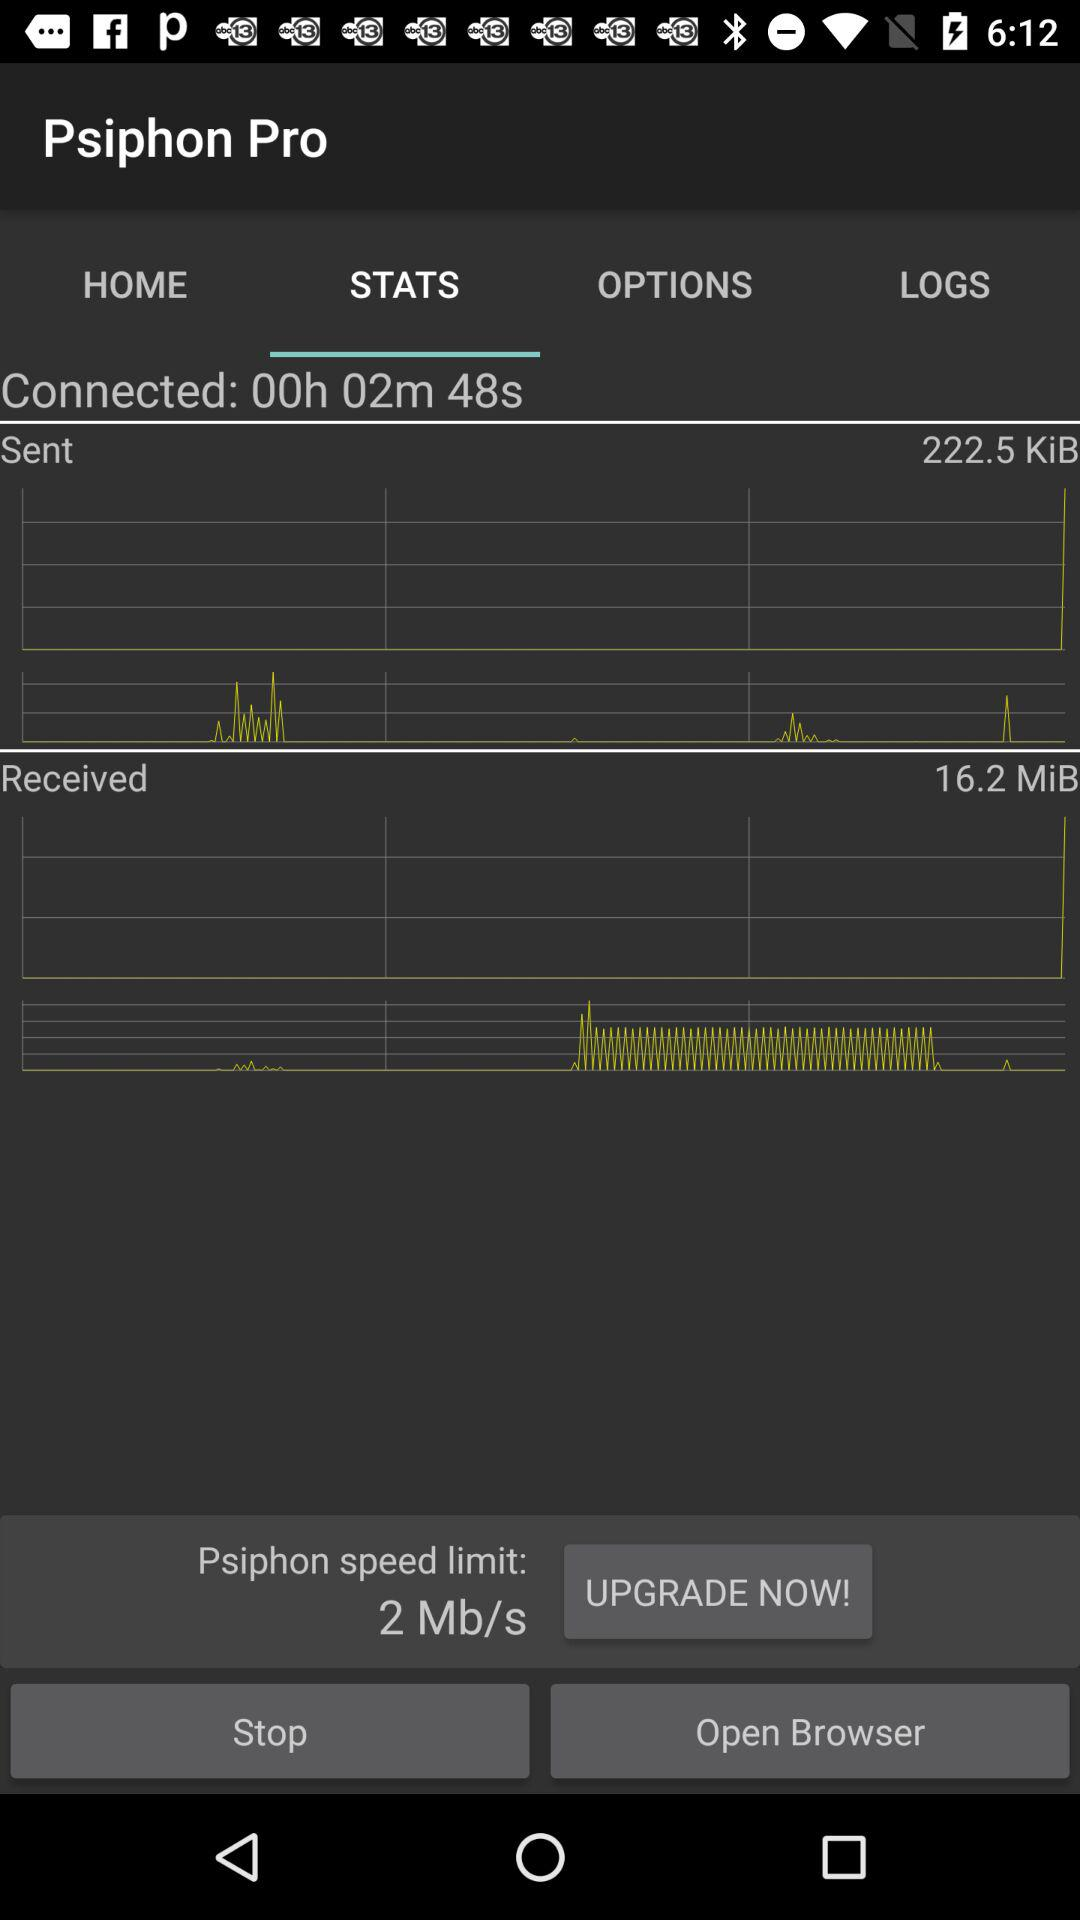How much data has been received? The data received is 16.2 MiB. 